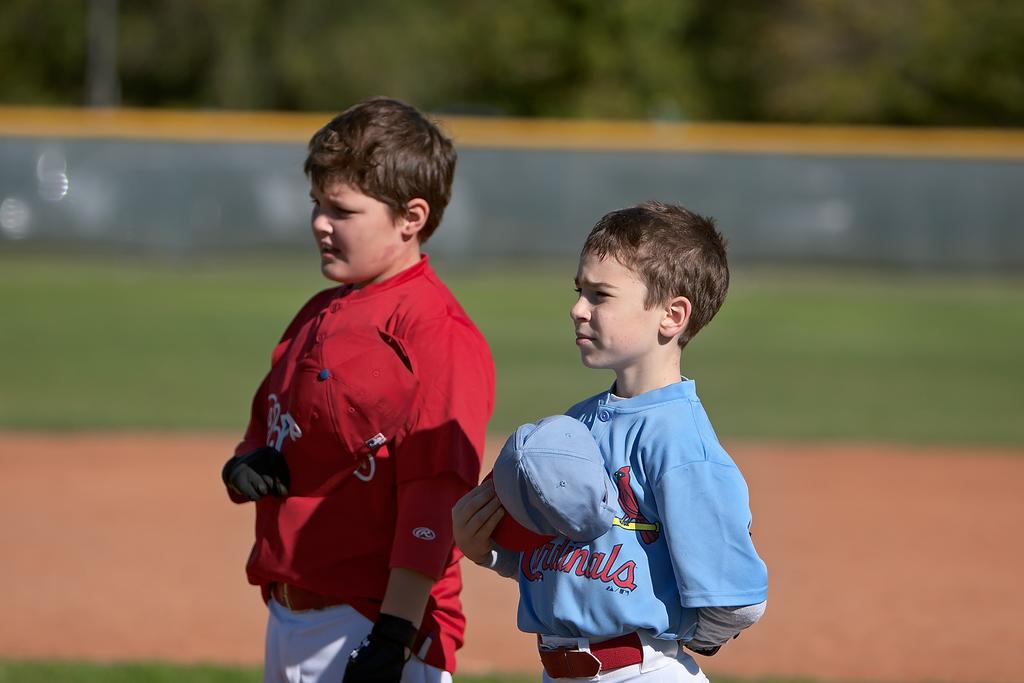<image>
Give a short and clear explanation of the subsequent image. two boys on a baseball field with one wearing a Cardinals shirt 